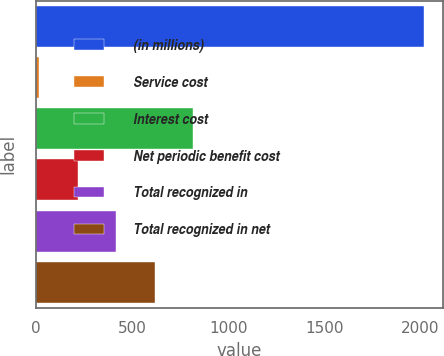<chart> <loc_0><loc_0><loc_500><loc_500><bar_chart><fcel>(in millions)<fcel>Service cost<fcel>Interest cost<fcel>Net periodic benefit cost<fcel>Total recognized in<fcel>Total recognized in net<nl><fcel>2016<fcel>19<fcel>817.8<fcel>218.7<fcel>418.4<fcel>618.1<nl></chart> 